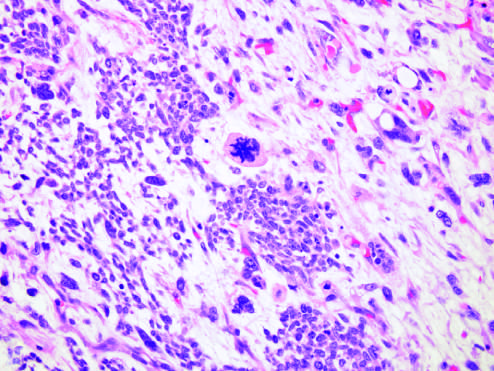re predominance of blastemal morphology and diffuse anaplasia associated with specific molecular lesions?
Answer the question using a single word or phrase. Yes 